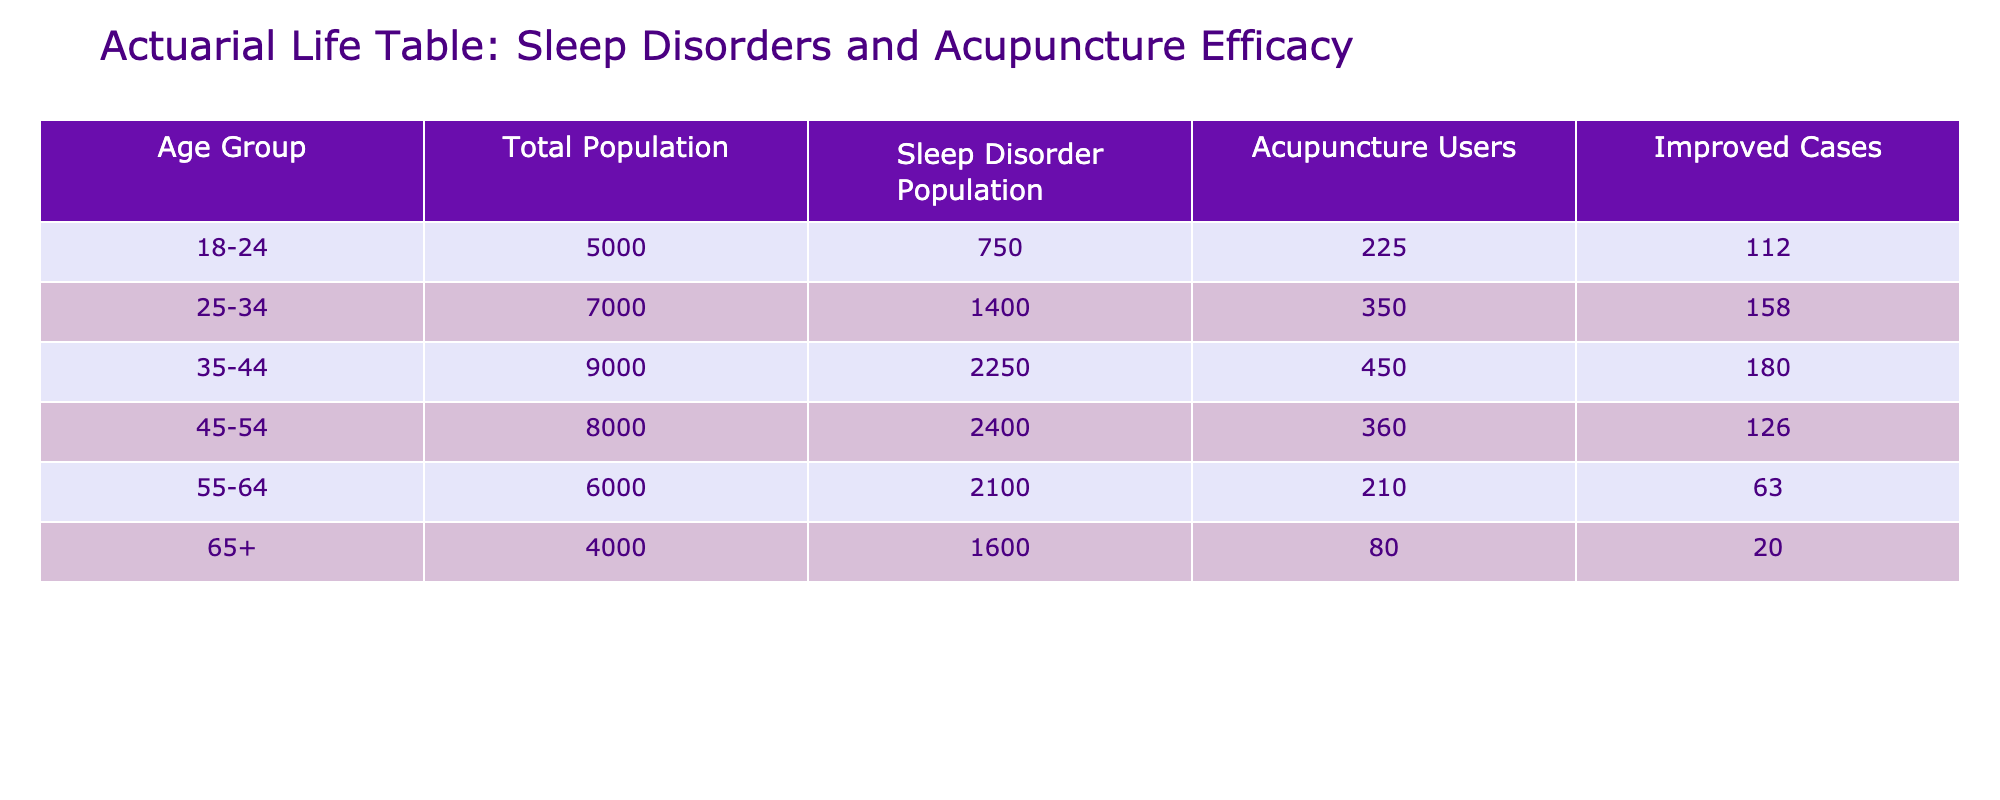What is the total population for the age group 45-54? From the table, the total population for the age group 45-54 is directly listed as 8000.
Answer: 8000 What percentage of the age group 35-44 is using acupuncture? The table shows that the acupuncture utilization percentage for the age group 35-44 is 20%.
Answer: 20% How many individuals aged 65 and over have sleep disorders? For the age group 65 and over, the total population is 4000 and the prevalence of sleep disorders is 40%. To calculate, multiply: 4000 * 0.40 = 1600 individuals with sleep disorders.
Answer: 1600 What is the difference in the number of improved cases between the age groups 25-34 and 45-54? The number of improved cases in the age group 25-34 is 45% of their acupuncture users, which is 25 users from a total of 7000 population resulting in 45 improved cases. For the age group 45-54 with 15% utilization yielding 35 cases, gives us an improved case count of 15. The difference is 45 - 15 = 30.
Answer: 30 Is the prevalence of sleep disorders higher in the age group 55-64 compared to the 18-24 age group? The prevalence of sleep disorders in the age group 55-64 is 35%, while in the 18-24 age group it is 15%. Since 35% is greater than 15%, this statement is true.
Answer: Yes How many total individuals across all age groups utilize acupuncture? Summing the "Acupuncture Users" from all groups gives: 1500 + 1750 + 450 + 120 + 60 + 20 = 3890. Thus, the total acupuncture users across all age groups is 3890.
Answer: 3890 For which age group is the improvement rate through acupuncture the highest? The improvement rate through acupuncture is highest in the age group 18-24 at 50%. Checking the rates in other groups confirms no group exceeds this percentage.
Answer: 18-24 What is the average number of individuals with sleep disorders across all age groups? To find the average, we sum the sleep disorder populations across all groups: 750 + 1400 + 2250 + 2400 + 2100 + 1600 = 10300, and divide by six age groups: 10300 / 6 ≈ 1716.67; rounding gives approximately 1717.
Answer: 1717 How many individuals aged 55-64 improved after receiving acupuncture? For the age group 55-64, taking the acupuncture users (60) and multiplying by the improvement rate of 30% (0.30), we find 60 * 0.30 = 18 improved cases.
Answer: 18 